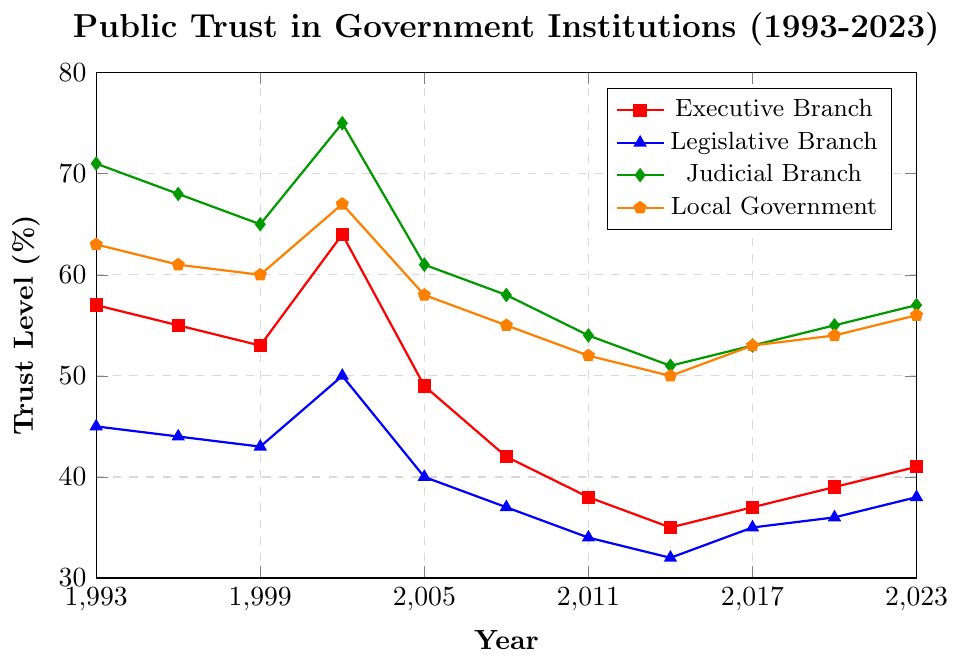What branch had the highest trust level in the year 2002? To find this, look at the 2002 data points for all branches and identify the highest one. The trust levels are: Executive Branch (64%), Legislative Branch (50%), Judicial Branch (75%), Local Government (67%). The highest value is 75%, which corresponds to the Judicial Branch.
Answer: Judicial Branch Which branch showed the largest drop in trust from 2002 to 2005? Calculate the difference in trust levels between 2002 and 2005 for each branch: Executive Branch (64% to 49% = -15), Legislative Branch (50% to 40% = -10), Judicial Branch (75% to 61% = -14), Local Government (67% to 58% = -9). The largest drop is -15 for the Executive Branch.
Answer: Executive Branch What is the average trust level for the Legislative Branch over the 30-year period? Add the trust levels for the Legislative Branch for each year and divide by the number of years (11): (45 + 44 + 43 + 50 + 40 + 37 + 34 + 32 + 35 + 36 + 38) / 11. The sum is 434 and dividing by 11 gives approximately 39.45%.
Answer: 39.45% Compare the trust levels between the Executive and Judicial branches in 2023. Which one is higher and by how much? In 2023, the trust level for the Executive Branch is 41% and for the Judicial Branch is 57%. The Judicial Branch has a higher trust level by 57% - 41% = 16%.
Answer: Judicial Branch by 16% Which branch had the lowest trust level in 2014? Look at the 2014 data points for all branches: Executive Branch (35%), Legislative Branch (32%), Judicial Branch (51%), Local Government (50%). The lowest value is 32%, which corresponds to the Legislative Branch.
Answer: Legislative Branch Between which years did the Local Government see an increase in trust levels? Examine the data points for the Local Government: increases occur between 2014 and 2017 (50% to 53%), and between 2017 and 2020 (53% to 54%), and between 2020 and 2023 (54% to 56%).
Answer: 2014-2017, 2017-2020, 2020-2023 What is the difference in trust levels between the Executive Branch in 1999 and 2008? Identify the trust levels for the Executive Branch in 1999 (53%) and 2008 (42%) and calculate the difference: 53% - 42% = 11%.
Answer: 11% In which year did the Judicial Branch have the highest trust level, and what was it? Compare the trust levels for the Judicial Branch across all years: the highest value is 75% in 2002.
Answer: 2002, 75% 